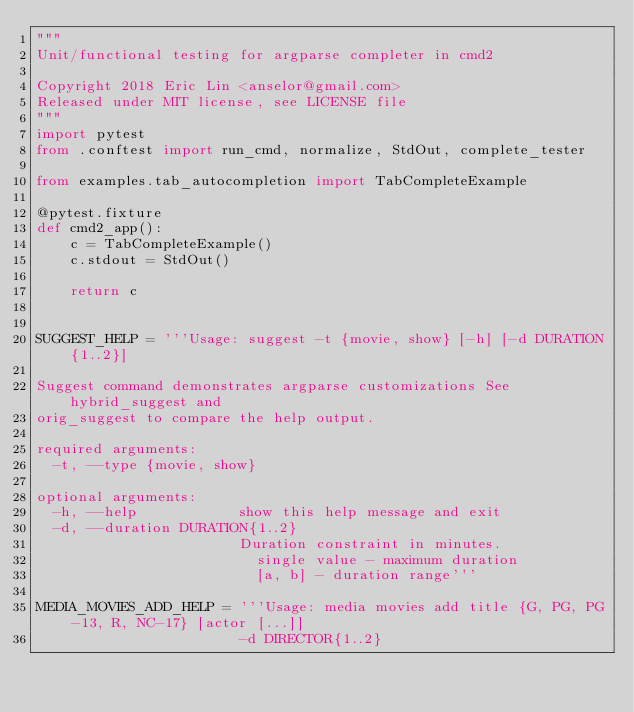<code> <loc_0><loc_0><loc_500><loc_500><_Python_>"""
Unit/functional testing for argparse completer in cmd2

Copyright 2018 Eric Lin <anselor@gmail.com>
Released under MIT license, see LICENSE file
"""
import pytest
from .conftest import run_cmd, normalize, StdOut, complete_tester

from examples.tab_autocompletion import TabCompleteExample

@pytest.fixture
def cmd2_app():
    c = TabCompleteExample()
    c.stdout = StdOut()

    return c


SUGGEST_HELP = '''Usage: suggest -t {movie, show} [-h] [-d DURATION{1..2}]

Suggest command demonstrates argparse customizations See hybrid_suggest and
orig_suggest to compare the help output.

required arguments:
  -t, --type {movie, show}

optional arguments:
  -h, --help            show this help message and exit
  -d, --duration DURATION{1..2}
                        Duration constraint in minutes.
                        	single value - maximum duration
                        	[a, b] - duration range'''

MEDIA_MOVIES_ADD_HELP = '''Usage: media movies add title {G, PG, PG-13, R, NC-17} [actor [...]]
                        -d DIRECTOR{1..2}</code> 